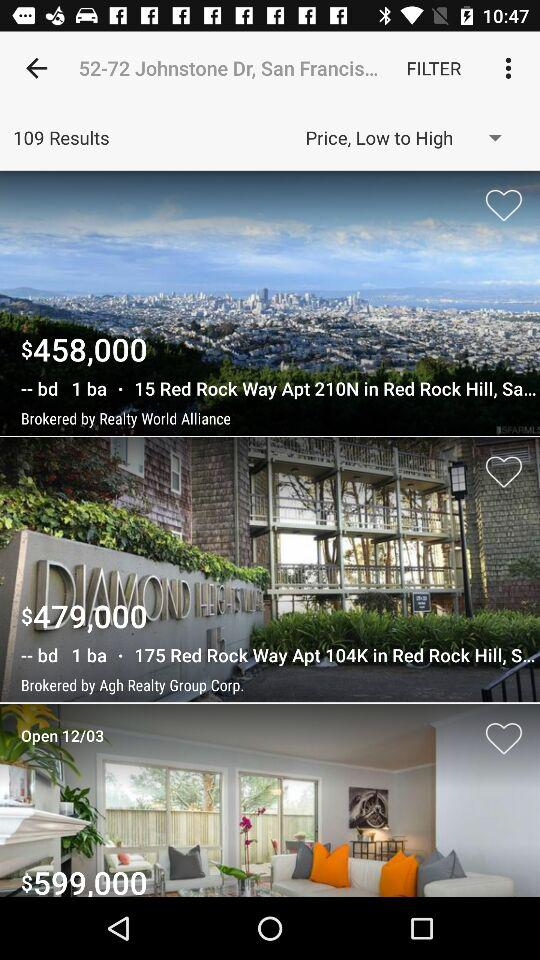What is the cost of 175 Red Rock Way apartment 104K in Red Rock Hill? The cost of 175 Red Rock Way apartment 104K in Red Rock Hill is $ 479,000. 